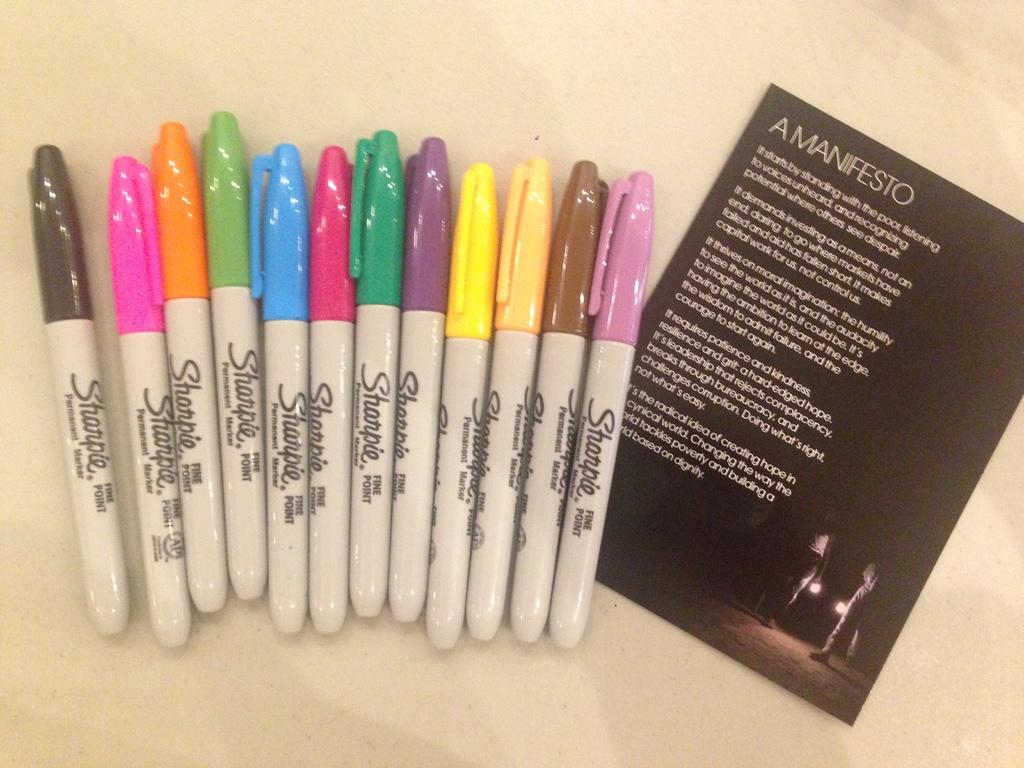What is the color of the card in the image? The card in the image is black. What can be used to draw or write on the card? There are markers of different colors in the image that can be used for drawing or writing. How many horses are depicted on the black card? There are no horses depicted on the black card; it is a plain black card with no images or designs. 